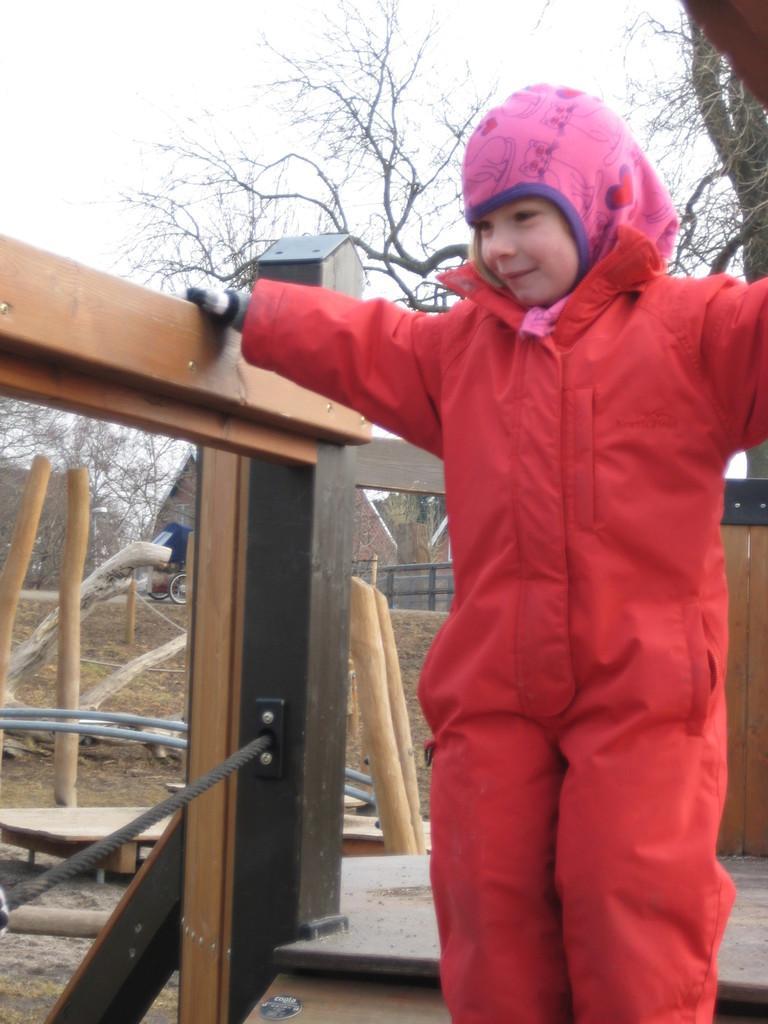Describe this image in one or two sentences. In this image there is a person standing, there is the sky, there are trees, there are tree truncated towards the right of the image, there is tree truncated towards the left of the image, there is an object truncated towards the left of the image, there are objects on the ground. 